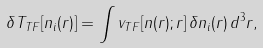Convert formula to latex. <formula><loc_0><loc_0><loc_500><loc_500>\delta T _ { T F } [ n _ { i } ( { r } ) ] = \int v _ { T F } [ n ( { r } ) ; { r } ] \, \delta n _ { i } ( { r } ) \, d ^ { 3 } r ,</formula> 